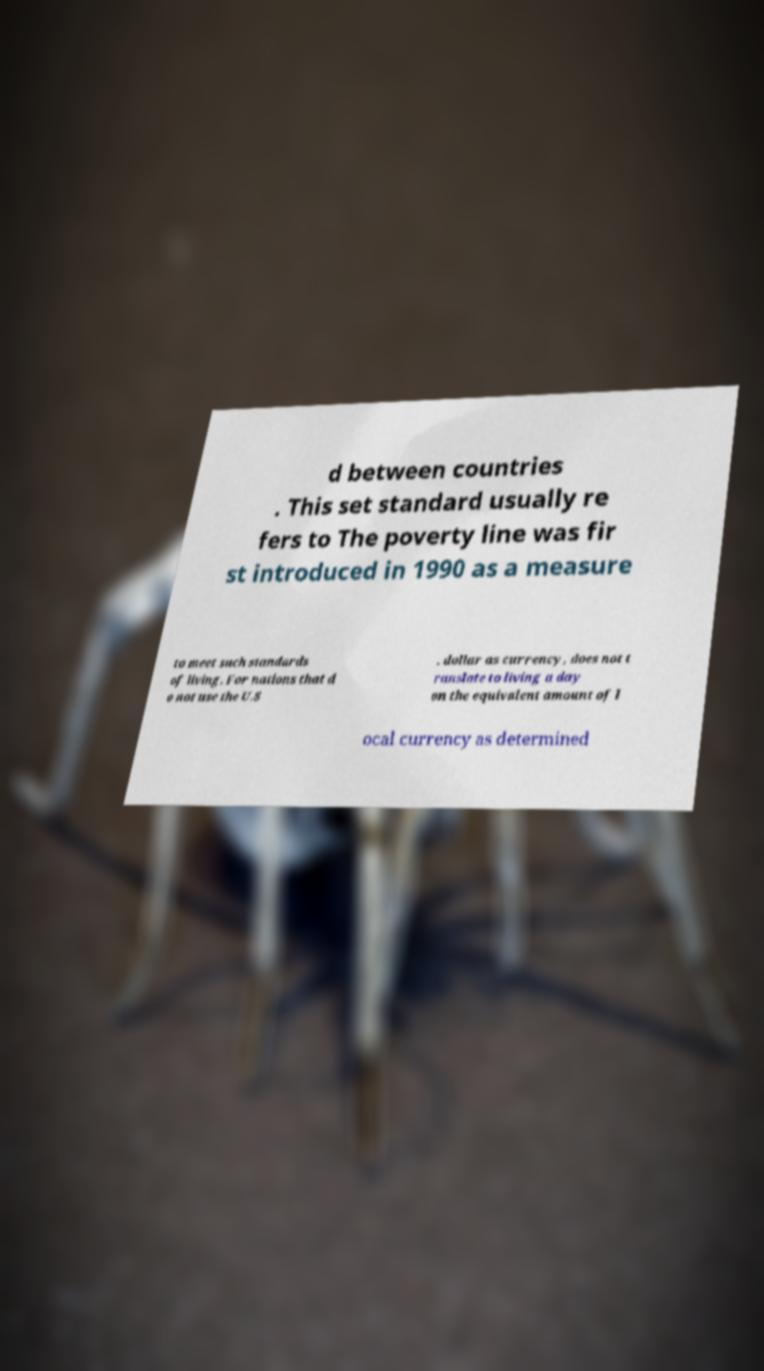Could you assist in decoding the text presented in this image and type it out clearly? d between countries . This set standard usually re fers to The poverty line was fir st introduced in 1990 as a measure to meet such standards of living. For nations that d o not use the U.S . dollar as currency, does not t ranslate to living a day on the equivalent amount of l ocal currency as determined 